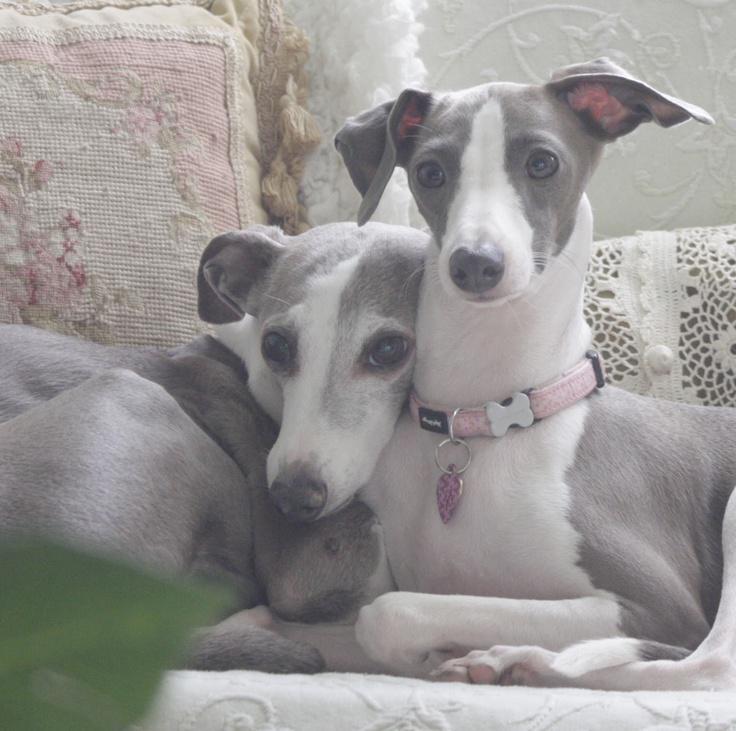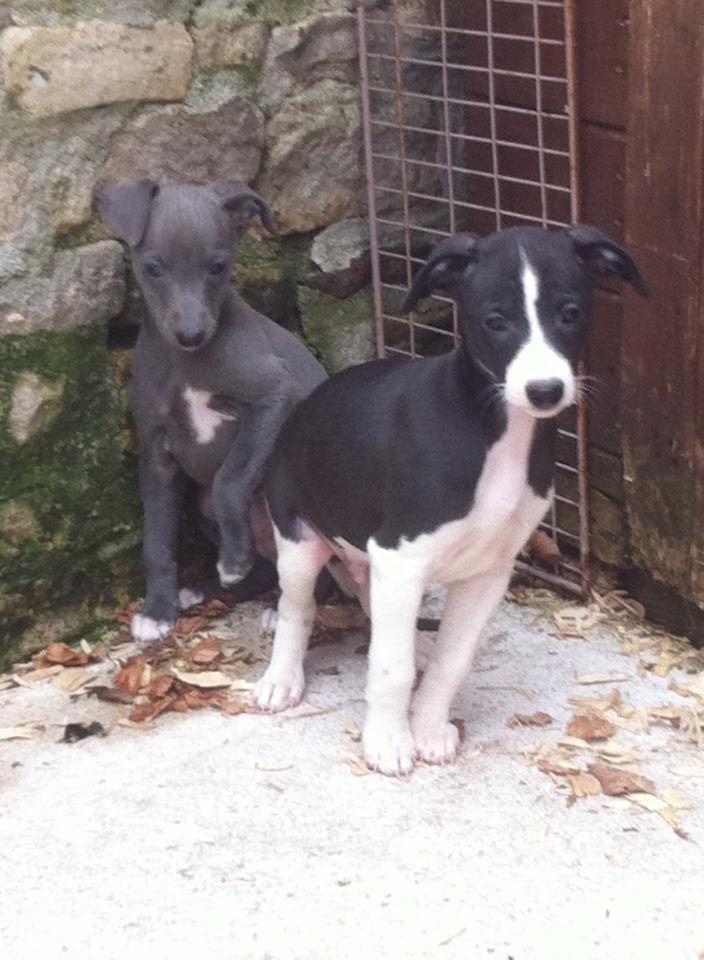The first image is the image on the left, the second image is the image on the right. Evaluate the accuracy of this statement regarding the images: "There are no more than two Italian greyhounds, all wearing collars.". Is it true? Answer yes or no. No. 